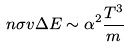<formula> <loc_0><loc_0><loc_500><loc_500>n \sigma v \Delta E \sim \alpha ^ { 2 } \frac { T ^ { 3 } } { m }</formula> 